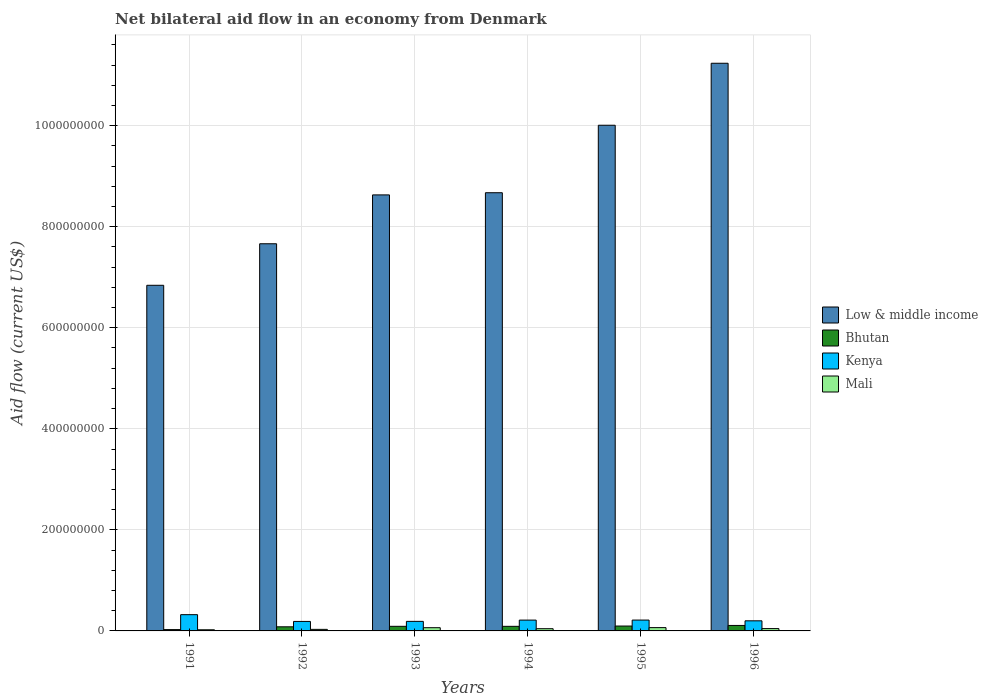How many groups of bars are there?
Your answer should be very brief. 6. How many bars are there on the 4th tick from the left?
Give a very brief answer. 4. How many bars are there on the 2nd tick from the right?
Your answer should be compact. 4. What is the net bilateral aid flow in Kenya in 1994?
Your response must be concise. 2.14e+07. Across all years, what is the maximum net bilateral aid flow in Kenya?
Provide a succinct answer. 3.22e+07. Across all years, what is the minimum net bilateral aid flow in Bhutan?
Give a very brief answer. 2.62e+06. In which year was the net bilateral aid flow in Kenya maximum?
Provide a short and direct response. 1991. In which year was the net bilateral aid flow in Bhutan minimum?
Give a very brief answer. 1991. What is the total net bilateral aid flow in Bhutan in the graph?
Ensure brevity in your answer.  4.95e+07. What is the difference between the net bilateral aid flow in Kenya in 1992 and that in 1994?
Offer a very short reply. -2.63e+06. What is the difference between the net bilateral aid flow in Mali in 1993 and the net bilateral aid flow in Kenya in 1994?
Offer a terse response. -1.50e+07. What is the average net bilateral aid flow in Mali per year?
Make the answer very short. 4.56e+06. In the year 1996, what is the difference between the net bilateral aid flow in Kenya and net bilateral aid flow in Mali?
Your response must be concise. 1.54e+07. What is the ratio of the net bilateral aid flow in Kenya in 1991 to that in 1995?
Give a very brief answer. 1.5. Is the difference between the net bilateral aid flow in Kenya in 1992 and 1993 greater than the difference between the net bilateral aid flow in Mali in 1992 and 1993?
Your response must be concise. Yes. What is the difference between the highest and the second highest net bilateral aid flow in Kenya?
Give a very brief answer. 1.07e+07. What is the difference between the highest and the lowest net bilateral aid flow in Kenya?
Provide a short and direct response. 1.34e+07. What does the 1st bar from the left in 1994 represents?
Make the answer very short. Low & middle income. What does the 4th bar from the right in 1991 represents?
Give a very brief answer. Low & middle income. Is it the case that in every year, the sum of the net bilateral aid flow in Low & middle income and net bilateral aid flow in Mali is greater than the net bilateral aid flow in Bhutan?
Offer a very short reply. Yes. How many years are there in the graph?
Offer a very short reply. 6. Are the values on the major ticks of Y-axis written in scientific E-notation?
Ensure brevity in your answer.  No. Does the graph contain any zero values?
Offer a terse response. No. What is the title of the graph?
Offer a terse response. Net bilateral aid flow in an economy from Denmark. Does "Iceland" appear as one of the legend labels in the graph?
Your response must be concise. No. What is the Aid flow (current US$) in Low & middle income in 1991?
Give a very brief answer. 6.84e+08. What is the Aid flow (current US$) of Bhutan in 1991?
Keep it short and to the point. 2.62e+06. What is the Aid flow (current US$) in Kenya in 1991?
Your response must be concise. 3.22e+07. What is the Aid flow (current US$) in Mali in 1991?
Your answer should be compact. 2.27e+06. What is the Aid flow (current US$) in Low & middle income in 1992?
Ensure brevity in your answer.  7.66e+08. What is the Aid flow (current US$) in Bhutan in 1992?
Provide a succinct answer. 8.16e+06. What is the Aid flow (current US$) in Kenya in 1992?
Offer a very short reply. 1.88e+07. What is the Aid flow (current US$) in Mali in 1992?
Offer a terse response. 3.08e+06. What is the Aid flow (current US$) of Low & middle income in 1993?
Give a very brief answer. 8.63e+08. What is the Aid flow (current US$) of Bhutan in 1993?
Offer a terse response. 9.12e+06. What is the Aid flow (current US$) of Kenya in 1993?
Your response must be concise. 1.89e+07. What is the Aid flow (current US$) of Mali in 1993?
Your answer should be very brief. 6.39e+06. What is the Aid flow (current US$) of Low & middle income in 1994?
Make the answer very short. 8.67e+08. What is the Aid flow (current US$) of Bhutan in 1994?
Ensure brevity in your answer.  9.07e+06. What is the Aid flow (current US$) of Kenya in 1994?
Your answer should be very brief. 2.14e+07. What is the Aid flow (current US$) of Mali in 1994?
Keep it short and to the point. 4.42e+06. What is the Aid flow (current US$) of Low & middle income in 1995?
Provide a short and direct response. 1.00e+09. What is the Aid flow (current US$) in Bhutan in 1995?
Your response must be concise. 9.65e+06. What is the Aid flow (current US$) of Kenya in 1995?
Make the answer very short. 2.15e+07. What is the Aid flow (current US$) of Mali in 1995?
Provide a succinct answer. 6.55e+06. What is the Aid flow (current US$) of Low & middle income in 1996?
Provide a succinct answer. 1.12e+09. What is the Aid flow (current US$) in Bhutan in 1996?
Your answer should be very brief. 1.08e+07. What is the Aid flow (current US$) in Kenya in 1996?
Offer a very short reply. 2.00e+07. What is the Aid flow (current US$) in Mali in 1996?
Offer a terse response. 4.63e+06. Across all years, what is the maximum Aid flow (current US$) of Low & middle income?
Give a very brief answer. 1.12e+09. Across all years, what is the maximum Aid flow (current US$) of Bhutan?
Offer a very short reply. 1.08e+07. Across all years, what is the maximum Aid flow (current US$) in Kenya?
Ensure brevity in your answer.  3.22e+07. Across all years, what is the maximum Aid flow (current US$) of Mali?
Keep it short and to the point. 6.55e+06. Across all years, what is the minimum Aid flow (current US$) of Low & middle income?
Your answer should be compact. 6.84e+08. Across all years, what is the minimum Aid flow (current US$) in Bhutan?
Provide a short and direct response. 2.62e+06. Across all years, what is the minimum Aid flow (current US$) in Kenya?
Provide a succinct answer. 1.88e+07. Across all years, what is the minimum Aid flow (current US$) in Mali?
Provide a succinct answer. 2.27e+06. What is the total Aid flow (current US$) of Low & middle income in the graph?
Keep it short and to the point. 5.30e+09. What is the total Aid flow (current US$) in Bhutan in the graph?
Provide a short and direct response. 4.95e+07. What is the total Aid flow (current US$) in Kenya in the graph?
Keep it short and to the point. 1.33e+08. What is the total Aid flow (current US$) in Mali in the graph?
Offer a very short reply. 2.73e+07. What is the difference between the Aid flow (current US$) in Low & middle income in 1991 and that in 1992?
Make the answer very short. -8.22e+07. What is the difference between the Aid flow (current US$) of Bhutan in 1991 and that in 1992?
Ensure brevity in your answer.  -5.54e+06. What is the difference between the Aid flow (current US$) of Kenya in 1991 and that in 1992?
Ensure brevity in your answer.  1.34e+07. What is the difference between the Aid flow (current US$) of Mali in 1991 and that in 1992?
Offer a very short reply. -8.10e+05. What is the difference between the Aid flow (current US$) in Low & middle income in 1991 and that in 1993?
Offer a very short reply. -1.79e+08. What is the difference between the Aid flow (current US$) in Bhutan in 1991 and that in 1993?
Your response must be concise. -6.50e+06. What is the difference between the Aid flow (current US$) in Kenya in 1991 and that in 1993?
Offer a terse response. 1.32e+07. What is the difference between the Aid flow (current US$) of Mali in 1991 and that in 1993?
Provide a succinct answer. -4.12e+06. What is the difference between the Aid flow (current US$) in Low & middle income in 1991 and that in 1994?
Your answer should be very brief. -1.83e+08. What is the difference between the Aid flow (current US$) of Bhutan in 1991 and that in 1994?
Your response must be concise. -6.45e+06. What is the difference between the Aid flow (current US$) of Kenya in 1991 and that in 1994?
Your answer should be compact. 1.08e+07. What is the difference between the Aid flow (current US$) in Mali in 1991 and that in 1994?
Your answer should be very brief. -2.15e+06. What is the difference between the Aid flow (current US$) of Low & middle income in 1991 and that in 1995?
Ensure brevity in your answer.  -3.17e+08. What is the difference between the Aid flow (current US$) of Bhutan in 1991 and that in 1995?
Make the answer very short. -7.03e+06. What is the difference between the Aid flow (current US$) of Kenya in 1991 and that in 1995?
Offer a terse response. 1.07e+07. What is the difference between the Aid flow (current US$) in Mali in 1991 and that in 1995?
Offer a terse response. -4.28e+06. What is the difference between the Aid flow (current US$) in Low & middle income in 1991 and that in 1996?
Give a very brief answer. -4.39e+08. What is the difference between the Aid flow (current US$) of Bhutan in 1991 and that in 1996?
Make the answer very short. -8.22e+06. What is the difference between the Aid flow (current US$) in Kenya in 1991 and that in 1996?
Provide a short and direct response. 1.22e+07. What is the difference between the Aid flow (current US$) in Mali in 1991 and that in 1996?
Provide a short and direct response. -2.36e+06. What is the difference between the Aid flow (current US$) of Low & middle income in 1992 and that in 1993?
Keep it short and to the point. -9.67e+07. What is the difference between the Aid flow (current US$) in Bhutan in 1992 and that in 1993?
Offer a terse response. -9.60e+05. What is the difference between the Aid flow (current US$) of Kenya in 1992 and that in 1993?
Offer a terse response. -1.30e+05. What is the difference between the Aid flow (current US$) in Mali in 1992 and that in 1993?
Keep it short and to the point. -3.31e+06. What is the difference between the Aid flow (current US$) of Low & middle income in 1992 and that in 1994?
Provide a succinct answer. -1.01e+08. What is the difference between the Aid flow (current US$) in Bhutan in 1992 and that in 1994?
Give a very brief answer. -9.10e+05. What is the difference between the Aid flow (current US$) of Kenya in 1992 and that in 1994?
Make the answer very short. -2.63e+06. What is the difference between the Aid flow (current US$) in Mali in 1992 and that in 1994?
Your response must be concise. -1.34e+06. What is the difference between the Aid flow (current US$) in Low & middle income in 1992 and that in 1995?
Your response must be concise. -2.35e+08. What is the difference between the Aid flow (current US$) in Bhutan in 1992 and that in 1995?
Your answer should be compact. -1.49e+06. What is the difference between the Aid flow (current US$) of Kenya in 1992 and that in 1995?
Provide a short and direct response. -2.68e+06. What is the difference between the Aid flow (current US$) in Mali in 1992 and that in 1995?
Offer a terse response. -3.47e+06. What is the difference between the Aid flow (current US$) in Low & middle income in 1992 and that in 1996?
Provide a short and direct response. -3.57e+08. What is the difference between the Aid flow (current US$) of Bhutan in 1992 and that in 1996?
Provide a succinct answer. -2.68e+06. What is the difference between the Aid flow (current US$) of Kenya in 1992 and that in 1996?
Your response must be concise. -1.21e+06. What is the difference between the Aid flow (current US$) in Mali in 1992 and that in 1996?
Your response must be concise. -1.55e+06. What is the difference between the Aid flow (current US$) of Low & middle income in 1993 and that in 1994?
Offer a terse response. -4.30e+06. What is the difference between the Aid flow (current US$) in Bhutan in 1993 and that in 1994?
Keep it short and to the point. 5.00e+04. What is the difference between the Aid flow (current US$) in Kenya in 1993 and that in 1994?
Keep it short and to the point. -2.50e+06. What is the difference between the Aid flow (current US$) of Mali in 1993 and that in 1994?
Your response must be concise. 1.97e+06. What is the difference between the Aid flow (current US$) of Low & middle income in 1993 and that in 1995?
Your answer should be compact. -1.38e+08. What is the difference between the Aid flow (current US$) in Bhutan in 1993 and that in 1995?
Your response must be concise. -5.30e+05. What is the difference between the Aid flow (current US$) in Kenya in 1993 and that in 1995?
Ensure brevity in your answer.  -2.55e+06. What is the difference between the Aid flow (current US$) in Low & middle income in 1993 and that in 1996?
Your answer should be very brief. -2.61e+08. What is the difference between the Aid flow (current US$) in Bhutan in 1993 and that in 1996?
Ensure brevity in your answer.  -1.72e+06. What is the difference between the Aid flow (current US$) in Kenya in 1993 and that in 1996?
Your answer should be very brief. -1.08e+06. What is the difference between the Aid flow (current US$) in Mali in 1993 and that in 1996?
Ensure brevity in your answer.  1.76e+06. What is the difference between the Aid flow (current US$) in Low & middle income in 1994 and that in 1995?
Provide a short and direct response. -1.34e+08. What is the difference between the Aid flow (current US$) in Bhutan in 1994 and that in 1995?
Give a very brief answer. -5.80e+05. What is the difference between the Aid flow (current US$) in Mali in 1994 and that in 1995?
Make the answer very short. -2.13e+06. What is the difference between the Aid flow (current US$) of Low & middle income in 1994 and that in 1996?
Keep it short and to the point. -2.56e+08. What is the difference between the Aid flow (current US$) of Bhutan in 1994 and that in 1996?
Provide a short and direct response. -1.77e+06. What is the difference between the Aid flow (current US$) in Kenya in 1994 and that in 1996?
Your answer should be compact. 1.42e+06. What is the difference between the Aid flow (current US$) of Mali in 1994 and that in 1996?
Offer a terse response. -2.10e+05. What is the difference between the Aid flow (current US$) in Low & middle income in 1995 and that in 1996?
Make the answer very short. -1.23e+08. What is the difference between the Aid flow (current US$) of Bhutan in 1995 and that in 1996?
Your response must be concise. -1.19e+06. What is the difference between the Aid flow (current US$) of Kenya in 1995 and that in 1996?
Offer a terse response. 1.47e+06. What is the difference between the Aid flow (current US$) of Mali in 1995 and that in 1996?
Keep it short and to the point. 1.92e+06. What is the difference between the Aid flow (current US$) in Low & middle income in 1991 and the Aid flow (current US$) in Bhutan in 1992?
Your answer should be compact. 6.76e+08. What is the difference between the Aid flow (current US$) of Low & middle income in 1991 and the Aid flow (current US$) of Kenya in 1992?
Your response must be concise. 6.65e+08. What is the difference between the Aid flow (current US$) of Low & middle income in 1991 and the Aid flow (current US$) of Mali in 1992?
Your answer should be compact. 6.81e+08. What is the difference between the Aid flow (current US$) of Bhutan in 1991 and the Aid flow (current US$) of Kenya in 1992?
Provide a short and direct response. -1.62e+07. What is the difference between the Aid flow (current US$) in Bhutan in 1991 and the Aid flow (current US$) in Mali in 1992?
Give a very brief answer. -4.60e+05. What is the difference between the Aid flow (current US$) in Kenya in 1991 and the Aid flow (current US$) in Mali in 1992?
Offer a very short reply. 2.91e+07. What is the difference between the Aid flow (current US$) of Low & middle income in 1991 and the Aid flow (current US$) of Bhutan in 1993?
Your answer should be compact. 6.75e+08. What is the difference between the Aid flow (current US$) in Low & middle income in 1991 and the Aid flow (current US$) in Kenya in 1993?
Ensure brevity in your answer.  6.65e+08. What is the difference between the Aid flow (current US$) of Low & middle income in 1991 and the Aid flow (current US$) of Mali in 1993?
Your response must be concise. 6.78e+08. What is the difference between the Aid flow (current US$) in Bhutan in 1991 and the Aid flow (current US$) in Kenya in 1993?
Your answer should be compact. -1.63e+07. What is the difference between the Aid flow (current US$) in Bhutan in 1991 and the Aid flow (current US$) in Mali in 1993?
Your answer should be very brief. -3.77e+06. What is the difference between the Aid flow (current US$) of Kenya in 1991 and the Aid flow (current US$) of Mali in 1993?
Your answer should be compact. 2.58e+07. What is the difference between the Aid flow (current US$) of Low & middle income in 1991 and the Aid flow (current US$) of Bhutan in 1994?
Your response must be concise. 6.75e+08. What is the difference between the Aid flow (current US$) of Low & middle income in 1991 and the Aid flow (current US$) of Kenya in 1994?
Give a very brief answer. 6.63e+08. What is the difference between the Aid flow (current US$) in Low & middle income in 1991 and the Aid flow (current US$) in Mali in 1994?
Your answer should be compact. 6.80e+08. What is the difference between the Aid flow (current US$) in Bhutan in 1991 and the Aid flow (current US$) in Kenya in 1994?
Your answer should be very brief. -1.88e+07. What is the difference between the Aid flow (current US$) in Bhutan in 1991 and the Aid flow (current US$) in Mali in 1994?
Your response must be concise. -1.80e+06. What is the difference between the Aid flow (current US$) in Kenya in 1991 and the Aid flow (current US$) in Mali in 1994?
Your answer should be very brief. 2.78e+07. What is the difference between the Aid flow (current US$) in Low & middle income in 1991 and the Aid flow (current US$) in Bhutan in 1995?
Your answer should be compact. 6.74e+08. What is the difference between the Aid flow (current US$) in Low & middle income in 1991 and the Aid flow (current US$) in Kenya in 1995?
Provide a succinct answer. 6.63e+08. What is the difference between the Aid flow (current US$) in Low & middle income in 1991 and the Aid flow (current US$) in Mali in 1995?
Keep it short and to the point. 6.77e+08. What is the difference between the Aid flow (current US$) of Bhutan in 1991 and the Aid flow (current US$) of Kenya in 1995?
Make the answer very short. -1.88e+07. What is the difference between the Aid flow (current US$) of Bhutan in 1991 and the Aid flow (current US$) of Mali in 1995?
Offer a very short reply. -3.93e+06. What is the difference between the Aid flow (current US$) of Kenya in 1991 and the Aid flow (current US$) of Mali in 1995?
Your answer should be compact. 2.56e+07. What is the difference between the Aid flow (current US$) of Low & middle income in 1991 and the Aid flow (current US$) of Bhutan in 1996?
Ensure brevity in your answer.  6.73e+08. What is the difference between the Aid flow (current US$) in Low & middle income in 1991 and the Aid flow (current US$) in Kenya in 1996?
Provide a succinct answer. 6.64e+08. What is the difference between the Aid flow (current US$) of Low & middle income in 1991 and the Aid flow (current US$) of Mali in 1996?
Provide a succinct answer. 6.79e+08. What is the difference between the Aid flow (current US$) in Bhutan in 1991 and the Aid flow (current US$) in Kenya in 1996?
Your answer should be very brief. -1.74e+07. What is the difference between the Aid flow (current US$) of Bhutan in 1991 and the Aid flow (current US$) of Mali in 1996?
Your answer should be very brief. -2.01e+06. What is the difference between the Aid flow (current US$) in Kenya in 1991 and the Aid flow (current US$) in Mali in 1996?
Provide a short and direct response. 2.75e+07. What is the difference between the Aid flow (current US$) in Low & middle income in 1992 and the Aid flow (current US$) in Bhutan in 1993?
Ensure brevity in your answer.  7.57e+08. What is the difference between the Aid flow (current US$) in Low & middle income in 1992 and the Aid flow (current US$) in Kenya in 1993?
Keep it short and to the point. 7.47e+08. What is the difference between the Aid flow (current US$) of Low & middle income in 1992 and the Aid flow (current US$) of Mali in 1993?
Offer a terse response. 7.60e+08. What is the difference between the Aid flow (current US$) of Bhutan in 1992 and the Aid flow (current US$) of Kenya in 1993?
Your answer should be very brief. -1.08e+07. What is the difference between the Aid flow (current US$) in Bhutan in 1992 and the Aid flow (current US$) in Mali in 1993?
Offer a very short reply. 1.77e+06. What is the difference between the Aid flow (current US$) of Kenya in 1992 and the Aid flow (current US$) of Mali in 1993?
Ensure brevity in your answer.  1.24e+07. What is the difference between the Aid flow (current US$) in Low & middle income in 1992 and the Aid flow (current US$) in Bhutan in 1994?
Ensure brevity in your answer.  7.57e+08. What is the difference between the Aid flow (current US$) in Low & middle income in 1992 and the Aid flow (current US$) in Kenya in 1994?
Keep it short and to the point. 7.45e+08. What is the difference between the Aid flow (current US$) of Low & middle income in 1992 and the Aid flow (current US$) of Mali in 1994?
Ensure brevity in your answer.  7.62e+08. What is the difference between the Aid flow (current US$) in Bhutan in 1992 and the Aid flow (current US$) in Kenya in 1994?
Keep it short and to the point. -1.33e+07. What is the difference between the Aid flow (current US$) of Bhutan in 1992 and the Aid flow (current US$) of Mali in 1994?
Ensure brevity in your answer.  3.74e+06. What is the difference between the Aid flow (current US$) of Kenya in 1992 and the Aid flow (current US$) of Mali in 1994?
Provide a short and direct response. 1.44e+07. What is the difference between the Aid flow (current US$) of Low & middle income in 1992 and the Aid flow (current US$) of Bhutan in 1995?
Provide a succinct answer. 7.57e+08. What is the difference between the Aid flow (current US$) of Low & middle income in 1992 and the Aid flow (current US$) of Kenya in 1995?
Provide a short and direct response. 7.45e+08. What is the difference between the Aid flow (current US$) in Low & middle income in 1992 and the Aid flow (current US$) in Mali in 1995?
Your response must be concise. 7.60e+08. What is the difference between the Aid flow (current US$) in Bhutan in 1992 and the Aid flow (current US$) in Kenya in 1995?
Offer a very short reply. -1.33e+07. What is the difference between the Aid flow (current US$) in Bhutan in 1992 and the Aid flow (current US$) in Mali in 1995?
Your answer should be compact. 1.61e+06. What is the difference between the Aid flow (current US$) in Kenya in 1992 and the Aid flow (current US$) in Mali in 1995?
Provide a succinct answer. 1.22e+07. What is the difference between the Aid flow (current US$) of Low & middle income in 1992 and the Aid flow (current US$) of Bhutan in 1996?
Ensure brevity in your answer.  7.55e+08. What is the difference between the Aid flow (current US$) of Low & middle income in 1992 and the Aid flow (current US$) of Kenya in 1996?
Your response must be concise. 7.46e+08. What is the difference between the Aid flow (current US$) in Low & middle income in 1992 and the Aid flow (current US$) in Mali in 1996?
Provide a succinct answer. 7.62e+08. What is the difference between the Aid flow (current US$) in Bhutan in 1992 and the Aid flow (current US$) in Kenya in 1996?
Your answer should be compact. -1.18e+07. What is the difference between the Aid flow (current US$) in Bhutan in 1992 and the Aid flow (current US$) in Mali in 1996?
Give a very brief answer. 3.53e+06. What is the difference between the Aid flow (current US$) of Kenya in 1992 and the Aid flow (current US$) of Mali in 1996?
Give a very brief answer. 1.42e+07. What is the difference between the Aid flow (current US$) of Low & middle income in 1993 and the Aid flow (current US$) of Bhutan in 1994?
Keep it short and to the point. 8.54e+08. What is the difference between the Aid flow (current US$) in Low & middle income in 1993 and the Aid flow (current US$) in Kenya in 1994?
Keep it short and to the point. 8.42e+08. What is the difference between the Aid flow (current US$) of Low & middle income in 1993 and the Aid flow (current US$) of Mali in 1994?
Your answer should be very brief. 8.59e+08. What is the difference between the Aid flow (current US$) of Bhutan in 1993 and the Aid flow (current US$) of Kenya in 1994?
Offer a terse response. -1.23e+07. What is the difference between the Aid flow (current US$) in Bhutan in 1993 and the Aid flow (current US$) in Mali in 1994?
Offer a terse response. 4.70e+06. What is the difference between the Aid flow (current US$) in Kenya in 1993 and the Aid flow (current US$) in Mali in 1994?
Your answer should be very brief. 1.45e+07. What is the difference between the Aid flow (current US$) in Low & middle income in 1993 and the Aid flow (current US$) in Bhutan in 1995?
Keep it short and to the point. 8.53e+08. What is the difference between the Aid flow (current US$) of Low & middle income in 1993 and the Aid flow (current US$) of Kenya in 1995?
Your answer should be very brief. 8.41e+08. What is the difference between the Aid flow (current US$) of Low & middle income in 1993 and the Aid flow (current US$) of Mali in 1995?
Make the answer very short. 8.56e+08. What is the difference between the Aid flow (current US$) of Bhutan in 1993 and the Aid flow (current US$) of Kenya in 1995?
Your answer should be very brief. -1.24e+07. What is the difference between the Aid flow (current US$) of Bhutan in 1993 and the Aid flow (current US$) of Mali in 1995?
Give a very brief answer. 2.57e+06. What is the difference between the Aid flow (current US$) of Kenya in 1993 and the Aid flow (current US$) of Mali in 1995?
Keep it short and to the point. 1.24e+07. What is the difference between the Aid flow (current US$) of Low & middle income in 1993 and the Aid flow (current US$) of Bhutan in 1996?
Ensure brevity in your answer.  8.52e+08. What is the difference between the Aid flow (current US$) of Low & middle income in 1993 and the Aid flow (current US$) of Kenya in 1996?
Make the answer very short. 8.43e+08. What is the difference between the Aid flow (current US$) of Low & middle income in 1993 and the Aid flow (current US$) of Mali in 1996?
Offer a terse response. 8.58e+08. What is the difference between the Aid flow (current US$) in Bhutan in 1993 and the Aid flow (current US$) in Kenya in 1996?
Your answer should be compact. -1.09e+07. What is the difference between the Aid flow (current US$) of Bhutan in 1993 and the Aid flow (current US$) of Mali in 1996?
Ensure brevity in your answer.  4.49e+06. What is the difference between the Aid flow (current US$) of Kenya in 1993 and the Aid flow (current US$) of Mali in 1996?
Your answer should be compact. 1.43e+07. What is the difference between the Aid flow (current US$) of Low & middle income in 1994 and the Aid flow (current US$) of Bhutan in 1995?
Make the answer very short. 8.58e+08. What is the difference between the Aid flow (current US$) of Low & middle income in 1994 and the Aid flow (current US$) of Kenya in 1995?
Make the answer very short. 8.46e+08. What is the difference between the Aid flow (current US$) of Low & middle income in 1994 and the Aid flow (current US$) of Mali in 1995?
Provide a succinct answer. 8.61e+08. What is the difference between the Aid flow (current US$) in Bhutan in 1994 and the Aid flow (current US$) in Kenya in 1995?
Offer a very short reply. -1.24e+07. What is the difference between the Aid flow (current US$) of Bhutan in 1994 and the Aid flow (current US$) of Mali in 1995?
Keep it short and to the point. 2.52e+06. What is the difference between the Aid flow (current US$) in Kenya in 1994 and the Aid flow (current US$) in Mali in 1995?
Your answer should be very brief. 1.49e+07. What is the difference between the Aid flow (current US$) of Low & middle income in 1994 and the Aid flow (current US$) of Bhutan in 1996?
Keep it short and to the point. 8.56e+08. What is the difference between the Aid flow (current US$) of Low & middle income in 1994 and the Aid flow (current US$) of Kenya in 1996?
Your answer should be very brief. 8.47e+08. What is the difference between the Aid flow (current US$) of Low & middle income in 1994 and the Aid flow (current US$) of Mali in 1996?
Provide a succinct answer. 8.63e+08. What is the difference between the Aid flow (current US$) of Bhutan in 1994 and the Aid flow (current US$) of Kenya in 1996?
Your answer should be very brief. -1.09e+07. What is the difference between the Aid flow (current US$) in Bhutan in 1994 and the Aid flow (current US$) in Mali in 1996?
Your answer should be very brief. 4.44e+06. What is the difference between the Aid flow (current US$) in Kenya in 1994 and the Aid flow (current US$) in Mali in 1996?
Make the answer very short. 1.68e+07. What is the difference between the Aid flow (current US$) of Low & middle income in 1995 and the Aid flow (current US$) of Bhutan in 1996?
Provide a succinct answer. 9.90e+08. What is the difference between the Aid flow (current US$) in Low & middle income in 1995 and the Aid flow (current US$) in Kenya in 1996?
Keep it short and to the point. 9.81e+08. What is the difference between the Aid flow (current US$) in Low & middle income in 1995 and the Aid flow (current US$) in Mali in 1996?
Offer a terse response. 9.96e+08. What is the difference between the Aid flow (current US$) in Bhutan in 1995 and the Aid flow (current US$) in Kenya in 1996?
Provide a succinct answer. -1.04e+07. What is the difference between the Aid flow (current US$) of Bhutan in 1995 and the Aid flow (current US$) of Mali in 1996?
Keep it short and to the point. 5.02e+06. What is the difference between the Aid flow (current US$) in Kenya in 1995 and the Aid flow (current US$) in Mali in 1996?
Your answer should be very brief. 1.68e+07. What is the average Aid flow (current US$) in Low & middle income per year?
Make the answer very short. 8.84e+08. What is the average Aid flow (current US$) in Bhutan per year?
Give a very brief answer. 8.24e+06. What is the average Aid flow (current US$) in Kenya per year?
Keep it short and to the point. 2.21e+07. What is the average Aid flow (current US$) in Mali per year?
Your answer should be very brief. 4.56e+06. In the year 1991, what is the difference between the Aid flow (current US$) of Low & middle income and Aid flow (current US$) of Bhutan?
Give a very brief answer. 6.81e+08. In the year 1991, what is the difference between the Aid flow (current US$) in Low & middle income and Aid flow (current US$) in Kenya?
Offer a terse response. 6.52e+08. In the year 1991, what is the difference between the Aid flow (current US$) in Low & middle income and Aid flow (current US$) in Mali?
Provide a succinct answer. 6.82e+08. In the year 1991, what is the difference between the Aid flow (current US$) in Bhutan and Aid flow (current US$) in Kenya?
Give a very brief answer. -2.96e+07. In the year 1991, what is the difference between the Aid flow (current US$) of Bhutan and Aid flow (current US$) of Mali?
Provide a succinct answer. 3.50e+05. In the year 1991, what is the difference between the Aid flow (current US$) in Kenya and Aid flow (current US$) in Mali?
Ensure brevity in your answer.  2.99e+07. In the year 1992, what is the difference between the Aid flow (current US$) of Low & middle income and Aid flow (current US$) of Bhutan?
Keep it short and to the point. 7.58e+08. In the year 1992, what is the difference between the Aid flow (current US$) in Low & middle income and Aid flow (current US$) in Kenya?
Keep it short and to the point. 7.47e+08. In the year 1992, what is the difference between the Aid flow (current US$) of Low & middle income and Aid flow (current US$) of Mali?
Your answer should be compact. 7.63e+08. In the year 1992, what is the difference between the Aid flow (current US$) of Bhutan and Aid flow (current US$) of Kenya?
Your answer should be compact. -1.06e+07. In the year 1992, what is the difference between the Aid flow (current US$) in Bhutan and Aid flow (current US$) in Mali?
Offer a terse response. 5.08e+06. In the year 1992, what is the difference between the Aid flow (current US$) in Kenya and Aid flow (current US$) in Mali?
Your answer should be very brief. 1.57e+07. In the year 1993, what is the difference between the Aid flow (current US$) in Low & middle income and Aid flow (current US$) in Bhutan?
Give a very brief answer. 8.54e+08. In the year 1993, what is the difference between the Aid flow (current US$) of Low & middle income and Aid flow (current US$) of Kenya?
Offer a very short reply. 8.44e+08. In the year 1993, what is the difference between the Aid flow (current US$) of Low & middle income and Aid flow (current US$) of Mali?
Your response must be concise. 8.57e+08. In the year 1993, what is the difference between the Aid flow (current US$) of Bhutan and Aid flow (current US$) of Kenya?
Offer a terse response. -9.80e+06. In the year 1993, what is the difference between the Aid flow (current US$) in Bhutan and Aid flow (current US$) in Mali?
Offer a terse response. 2.73e+06. In the year 1993, what is the difference between the Aid flow (current US$) of Kenya and Aid flow (current US$) of Mali?
Make the answer very short. 1.25e+07. In the year 1994, what is the difference between the Aid flow (current US$) of Low & middle income and Aid flow (current US$) of Bhutan?
Offer a terse response. 8.58e+08. In the year 1994, what is the difference between the Aid flow (current US$) in Low & middle income and Aid flow (current US$) in Kenya?
Offer a very short reply. 8.46e+08. In the year 1994, what is the difference between the Aid flow (current US$) of Low & middle income and Aid flow (current US$) of Mali?
Make the answer very short. 8.63e+08. In the year 1994, what is the difference between the Aid flow (current US$) in Bhutan and Aid flow (current US$) in Kenya?
Offer a terse response. -1.24e+07. In the year 1994, what is the difference between the Aid flow (current US$) of Bhutan and Aid flow (current US$) of Mali?
Give a very brief answer. 4.65e+06. In the year 1994, what is the difference between the Aid flow (current US$) in Kenya and Aid flow (current US$) in Mali?
Make the answer very short. 1.70e+07. In the year 1995, what is the difference between the Aid flow (current US$) in Low & middle income and Aid flow (current US$) in Bhutan?
Provide a short and direct response. 9.91e+08. In the year 1995, what is the difference between the Aid flow (current US$) of Low & middle income and Aid flow (current US$) of Kenya?
Ensure brevity in your answer.  9.79e+08. In the year 1995, what is the difference between the Aid flow (current US$) in Low & middle income and Aid flow (current US$) in Mali?
Your answer should be very brief. 9.94e+08. In the year 1995, what is the difference between the Aid flow (current US$) in Bhutan and Aid flow (current US$) in Kenya?
Keep it short and to the point. -1.18e+07. In the year 1995, what is the difference between the Aid flow (current US$) in Bhutan and Aid flow (current US$) in Mali?
Provide a succinct answer. 3.10e+06. In the year 1995, what is the difference between the Aid flow (current US$) in Kenya and Aid flow (current US$) in Mali?
Offer a very short reply. 1.49e+07. In the year 1996, what is the difference between the Aid flow (current US$) of Low & middle income and Aid flow (current US$) of Bhutan?
Keep it short and to the point. 1.11e+09. In the year 1996, what is the difference between the Aid flow (current US$) of Low & middle income and Aid flow (current US$) of Kenya?
Give a very brief answer. 1.10e+09. In the year 1996, what is the difference between the Aid flow (current US$) of Low & middle income and Aid flow (current US$) of Mali?
Give a very brief answer. 1.12e+09. In the year 1996, what is the difference between the Aid flow (current US$) of Bhutan and Aid flow (current US$) of Kenya?
Your answer should be compact. -9.16e+06. In the year 1996, what is the difference between the Aid flow (current US$) of Bhutan and Aid flow (current US$) of Mali?
Give a very brief answer. 6.21e+06. In the year 1996, what is the difference between the Aid flow (current US$) of Kenya and Aid flow (current US$) of Mali?
Ensure brevity in your answer.  1.54e+07. What is the ratio of the Aid flow (current US$) of Low & middle income in 1991 to that in 1992?
Offer a very short reply. 0.89. What is the ratio of the Aid flow (current US$) in Bhutan in 1991 to that in 1992?
Provide a short and direct response. 0.32. What is the ratio of the Aid flow (current US$) of Kenya in 1991 to that in 1992?
Offer a terse response. 1.71. What is the ratio of the Aid flow (current US$) in Mali in 1991 to that in 1992?
Keep it short and to the point. 0.74. What is the ratio of the Aid flow (current US$) in Low & middle income in 1991 to that in 1993?
Keep it short and to the point. 0.79. What is the ratio of the Aid flow (current US$) of Bhutan in 1991 to that in 1993?
Your response must be concise. 0.29. What is the ratio of the Aid flow (current US$) of Kenya in 1991 to that in 1993?
Offer a very short reply. 1.7. What is the ratio of the Aid flow (current US$) of Mali in 1991 to that in 1993?
Keep it short and to the point. 0.36. What is the ratio of the Aid flow (current US$) in Low & middle income in 1991 to that in 1994?
Ensure brevity in your answer.  0.79. What is the ratio of the Aid flow (current US$) of Bhutan in 1991 to that in 1994?
Offer a very short reply. 0.29. What is the ratio of the Aid flow (current US$) in Kenya in 1991 to that in 1994?
Your answer should be very brief. 1.5. What is the ratio of the Aid flow (current US$) of Mali in 1991 to that in 1994?
Your answer should be compact. 0.51. What is the ratio of the Aid flow (current US$) in Low & middle income in 1991 to that in 1995?
Offer a terse response. 0.68. What is the ratio of the Aid flow (current US$) of Bhutan in 1991 to that in 1995?
Your answer should be compact. 0.27. What is the ratio of the Aid flow (current US$) in Kenya in 1991 to that in 1995?
Ensure brevity in your answer.  1.5. What is the ratio of the Aid flow (current US$) in Mali in 1991 to that in 1995?
Your answer should be compact. 0.35. What is the ratio of the Aid flow (current US$) of Low & middle income in 1991 to that in 1996?
Give a very brief answer. 0.61. What is the ratio of the Aid flow (current US$) in Bhutan in 1991 to that in 1996?
Your answer should be compact. 0.24. What is the ratio of the Aid flow (current US$) of Kenya in 1991 to that in 1996?
Ensure brevity in your answer.  1.61. What is the ratio of the Aid flow (current US$) in Mali in 1991 to that in 1996?
Provide a short and direct response. 0.49. What is the ratio of the Aid flow (current US$) of Low & middle income in 1992 to that in 1993?
Give a very brief answer. 0.89. What is the ratio of the Aid flow (current US$) in Bhutan in 1992 to that in 1993?
Keep it short and to the point. 0.89. What is the ratio of the Aid flow (current US$) in Mali in 1992 to that in 1993?
Your response must be concise. 0.48. What is the ratio of the Aid flow (current US$) of Low & middle income in 1992 to that in 1994?
Give a very brief answer. 0.88. What is the ratio of the Aid flow (current US$) of Bhutan in 1992 to that in 1994?
Provide a succinct answer. 0.9. What is the ratio of the Aid flow (current US$) of Kenya in 1992 to that in 1994?
Your response must be concise. 0.88. What is the ratio of the Aid flow (current US$) in Mali in 1992 to that in 1994?
Your answer should be compact. 0.7. What is the ratio of the Aid flow (current US$) in Low & middle income in 1992 to that in 1995?
Keep it short and to the point. 0.77. What is the ratio of the Aid flow (current US$) in Bhutan in 1992 to that in 1995?
Keep it short and to the point. 0.85. What is the ratio of the Aid flow (current US$) in Kenya in 1992 to that in 1995?
Provide a short and direct response. 0.88. What is the ratio of the Aid flow (current US$) of Mali in 1992 to that in 1995?
Give a very brief answer. 0.47. What is the ratio of the Aid flow (current US$) in Low & middle income in 1992 to that in 1996?
Your answer should be very brief. 0.68. What is the ratio of the Aid flow (current US$) of Bhutan in 1992 to that in 1996?
Keep it short and to the point. 0.75. What is the ratio of the Aid flow (current US$) in Kenya in 1992 to that in 1996?
Your response must be concise. 0.94. What is the ratio of the Aid flow (current US$) in Mali in 1992 to that in 1996?
Offer a very short reply. 0.67. What is the ratio of the Aid flow (current US$) in Bhutan in 1993 to that in 1994?
Your answer should be very brief. 1.01. What is the ratio of the Aid flow (current US$) in Kenya in 1993 to that in 1994?
Offer a terse response. 0.88. What is the ratio of the Aid flow (current US$) in Mali in 1993 to that in 1994?
Offer a terse response. 1.45. What is the ratio of the Aid flow (current US$) of Low & middle income in 1993 to that in 1995?
Ensure brevity in your answer.  0.86. What is the ratio of the Aid flow (current US$) in Bhutan in 1993 to that in 1995?
Offer a terse response. 0.95. What is the ratio of the Aid flow (current US$) of Kenya in 1993 to that in 1995?
Provide a short and direct response. 0.88. What is the ratio of the Aid flow (current US$) in Mali in 1993 to that in 1995?
Your response must be concise. 0.98. What is the ratio of the Aid flow (current US$) of Low & middle income in 1993 to that in 1996?
Offer a very short reply. 0.77. What is the ratio of the Aid flow (current US$) in Bhutan in 1993 to that in 1996?
Make the answer very short. 0.84. What is the ratio of the Aid flow (current US$) in Kenya in 1993 to that in 1996?
Offer a very short reply. 0.95. What is the ratio of the Aid flow (current US$) in Mali in 1993 to that in 1996?
Your answer should be very brief. 1.38. What is the ratio of the Aid flow (current US$) in Low & middle income in 1994 to that in 1995?
Make the answer very short. 0.87. What is the ratio of the Aid flow (current US$) of Bhutan in 1994 to that in 1995?
Provide a short and direct response. 0.94. What is the ratio of the Aid flow (current US$) of Mali in 1994 to that in 1995?
Your response must be concise. 0.67. What is the ratio of the Aid flow (current US$) of Low & middle income in 1994 to that in 1996?
Provide a short and direct response. 0.77. What is the ratio of the Aid flow (current US$) in Bhutan in 1994 to that in 1996?
Offer a terse response. 0.84. What is the ratio of the Aid flow (current US$) in Kenya in 1994 to that in 1996?
Your response must be concise. 1.07. What is the ratio of the Aid flow (current US$) in Mali in 1994 to that in 1996?
Your answer should be compact. 0.95. What is the ratio of the Aid flow (current US$) of Low & middle income in 1995 to that in 1996?
Make the answer very short. 0.89. What is the ratio of the Aid flow (current US$) in Bhutan in 1995 to that in 1996?
Provide a short and direct response. 0.89. What is the ratio of the Aid flow (current US$) of Kenya in 1995 to that in 1996?
Your answer should be very brief. 1.07. What is the ratio of the Aid flow (current US$) of Mali in 1995 to that in 1996?
Keep it short and to the point. 1.41. What is the difference between the highest and the second highest Aid flow (current US$) of Low & middle income?
Keep it short and to the point. 1.23e+08. What is the difference between the highest and the second highest Aid flow (current US$) of Bhutan?
Your answer should be compact. 1.19e+06. What is the difference between the highest and the second highest Aid flow (current US$) in Kenya?
Keep it short and to the point. 1.07e+07. What is the difference between the highest and the second highest Aid flow (current US$) in Mali?
Ensure brevity in your answer.  1.60e+05. What is the difference between the highest and the lowest Aid flow (current US$) in Low & middle income?
Your answer should be compact. 4.39e+08. What is the difference between the highest and the lowest Aid flow (current US$) in Bhutan?
Keep it short and to the point. 8.22e+06. What is the difference between the highest and the lowest Aid flow (current US$) in Kenya?
Make the answer very short. 1.34e+07. What is the difference between the highest and the lowest Aid flow (current US$) of Mali?
Make the answer very short. 4.28e+06. 